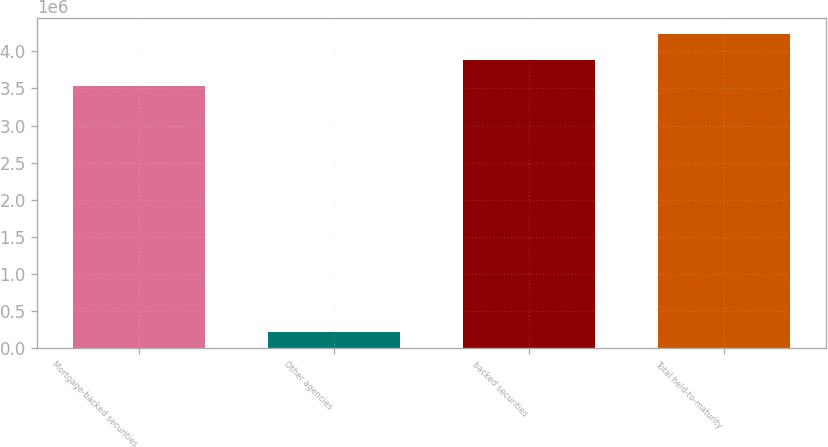<chart> <loc_0><loc_0><loc_500><loc_500><bar_chart><fcel>Mortgage-backed securities<fcel>Other agencies<fcel>backed securities<fcel>Total held-to-maturity<nl><fcel>3.52857e+06<fcel>224172<fcel>3.88224e+06<fcel>4.23591e+06<nl></chart> 